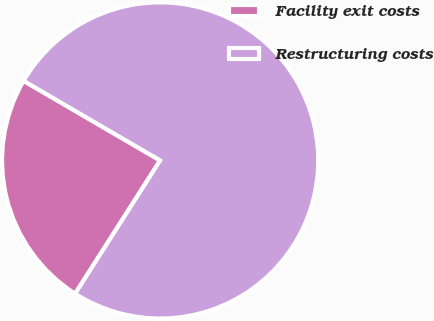<chart> <loc_0><loc_0><loc_500><loc_500><pie_chart><fcel>Facility exit costs<fcel>Restructuring costs<nl><fcel>24.36%<fcel>75.64%<nl></chart> 